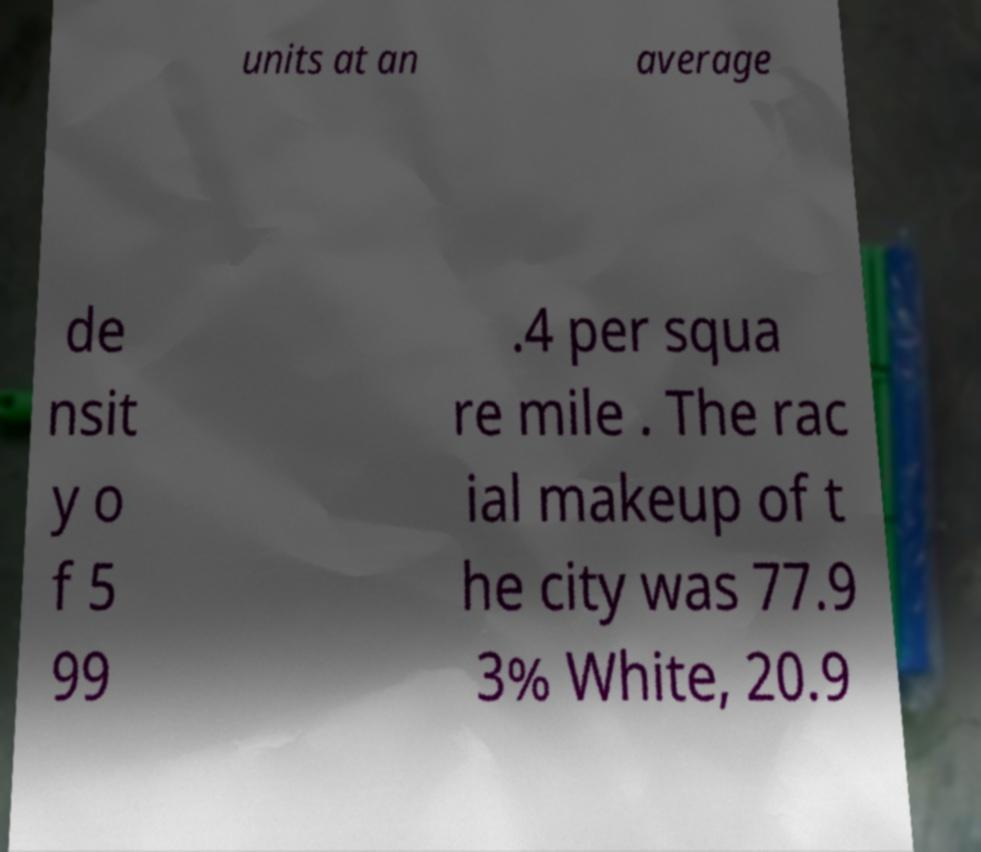For documentation purposes, I need the text within this image transcribed. Could you provide that? units at an average de nsit y o f 5 99 .4 per squa re mile . The rac ial makeup of t he city was 77.9 3% White, 20.9 